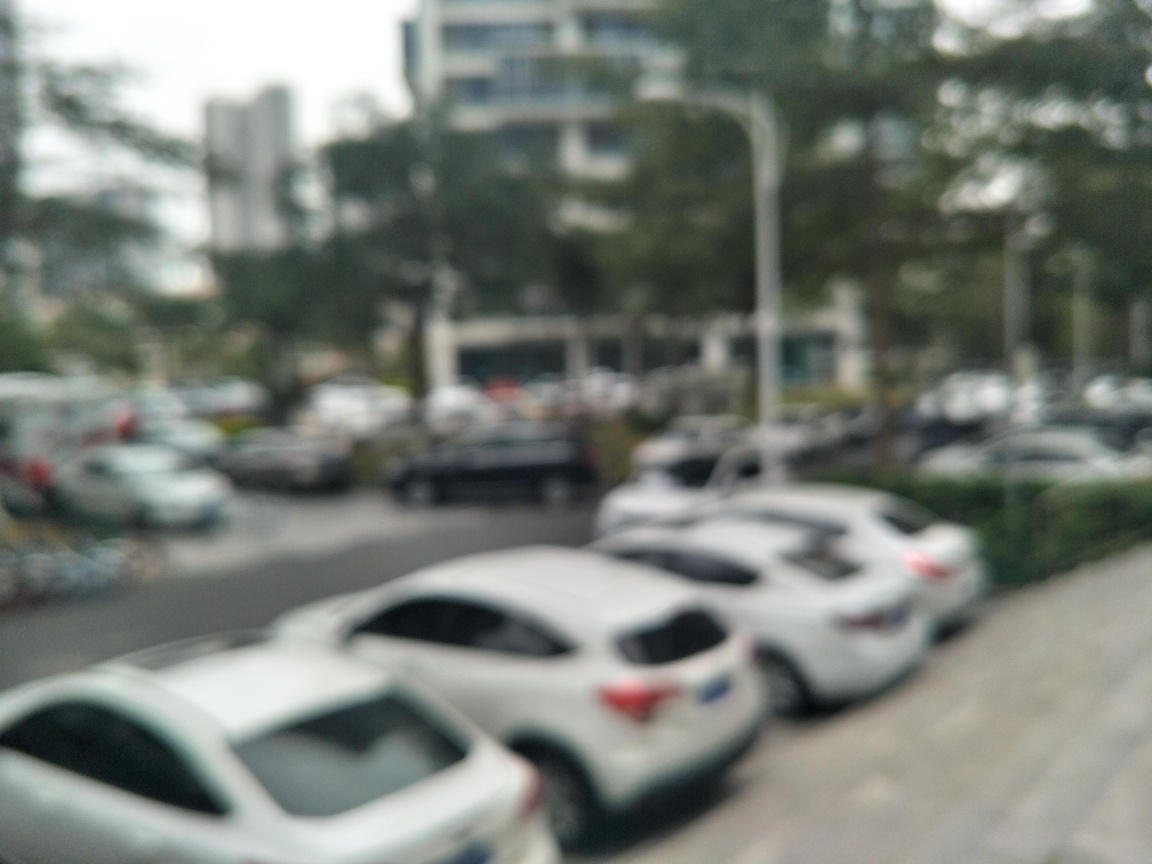What might be the reason for taking a photo like this? This image may have been taken unintentionally while the camera was moving, resulting in a loss of focus. Another possibility is that it's an artistic choice, aiming to capture the hustle and bustle of city life in an abstract way, emphasizing the feeling of motion and chaos. 